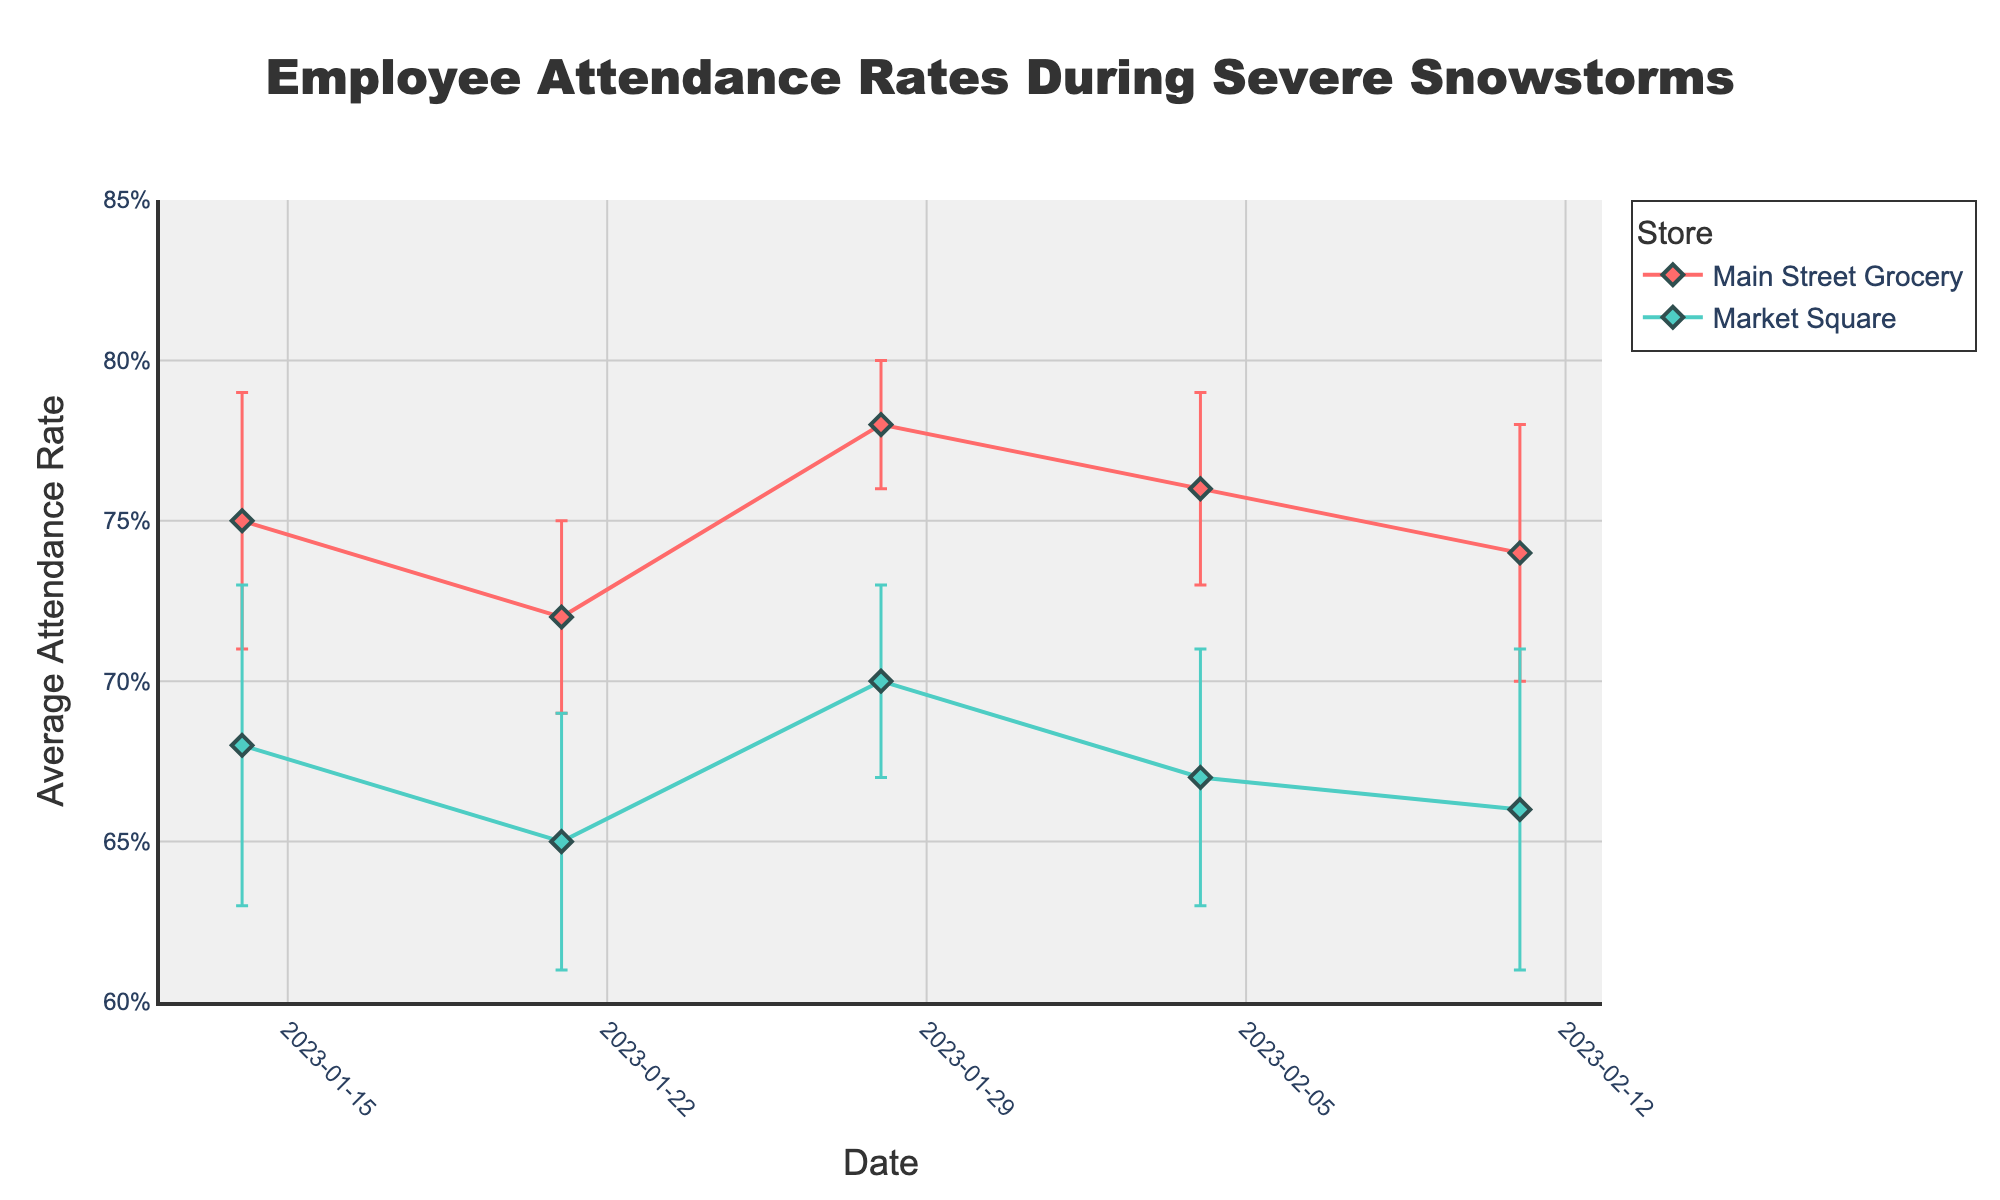What is the title of the plot? The title is usually displayed at the top of the plot. In this case, it is "Employee Attendance Rates During Severe Snowstorms."
Answer: Employee Attendance Rates During Severe Snowstorms What do the error bars represent in this plot? Error bars typically represent the standard deviation or standard error of the data points. In this plot, the error bars show the standard deviation of the average attendance rate for each store on different dates.
Answer: Standard deviation Which store has the highest average attendance rate on 2023-01-28? By examining the data points for 2023-01-28, we observe that Main Street Grocery has an average attendance rate of 0.78, whereas Market Square has 0.70. Therefore, Main Street Grocery has the higher rate.
Answer: Main Street Grocery Between which dates does Main Street Grocery show the highest variation in attendance rates? We can find the variation by checking the standard deviation values for Main Street Grocery. The highest standard deviation is on 2023-01-14 (0.04) and 2023-02-11 (0.04).
Answer: 2023-01-14 and 2023-02-11 Which store showed a consistent rise in average attendance rate over the given period? By plotting the trend lines, we see that Market Square had an initial dip but showed a rise afterward. Main Street Grocery essentially fluctuated around its initial levels. Thus, Market Square shows a rise around the middle periods.
Answer: Market Square How does the average attendance rate of Main Street Grocery on 2023-02-04 compare to 2023-01-21? Compare the attendance rates of Main Street Grocery on these dates. On 2023-02-04, it's 0.76, and on 2023-01-21, it’s 0.72. The rate on 2023-02-04 is higher by 0.04.
Answer: Higher by 0.04 Which date has the lowest average attendance rate for Market Square? Scan through the dates for Market Square. The lowest average attendance rate is on 2023-01-21 with a rate of 0.65.
Answer: 2023-01-21 Between Main Street Grocery and Market Square, which store has a smaller standard deviation on average? Calculate the standard deviation for each store, add them up and divide by the number of data points. Main Street Grocery: (0.04 + 0.03 + 0.02 + 0.03 + 0.04) / 5 = 0.032, Market Square: (0.05 + 0.04 + 0.03 + 0.04 + 0.05) / 5 = 0.042. Thus, Main Street Grocery has a smaller average standard deviation.
Answer: Main Street Grocery What is the overall trend in employee attendance rates for both stores? Analyze the data points for both stores over time. Both stores show some fluctuations; however, there isn’t a discernable upward or downward trend for either store over the entire period.
Answer: Fluctuating How does the range of attendance rates for Main Street Grocery compare with Market Square on 2023-01-14? Consider the standard deviation to calculate the range. For Main Street Grocery: 0.75 ± 0.04 gives a range of [0.71, 0.79]. For Market Square: 0.68 ± 0.05 gives a range of [0.63, 0.73]. Main Street Grocery has a higher and narrower range.
Answer: Higher and narrower 